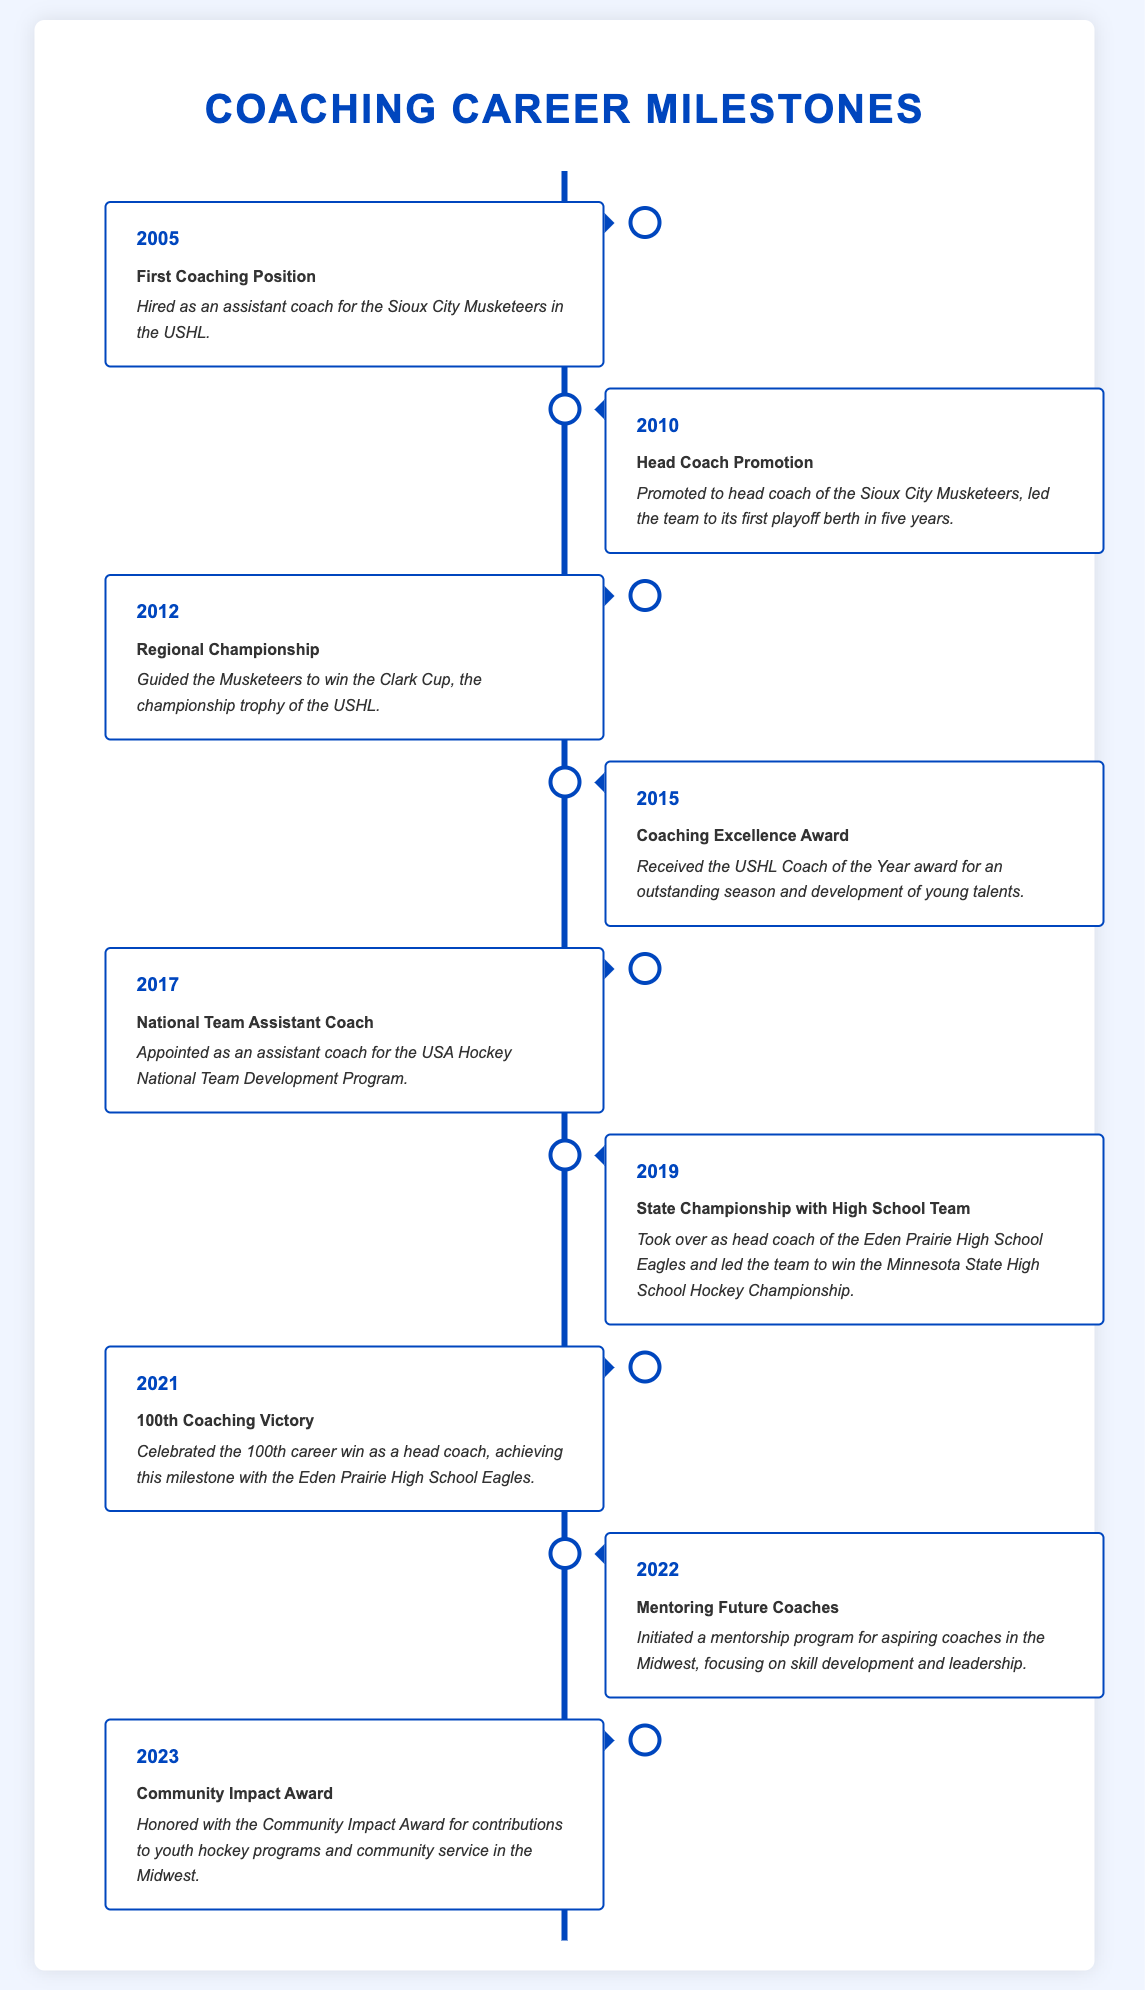what year did the coach start their career? The coach's first coaching position began in 2005, as an assistant coach for the Sioux City Musketeers.
Answer: 2005 which championship did the Musketeers win? The Musketeers won the Clark Cup, the championship trophy of the USHL in 2012.
Answer: Clark Cup how many coaching victories did the coach celebrate in 2021? The coach celebrated his 100th career win as a head coach in 2021.
Answer: 100th what achievement was received in 2015? The coach was awarded the USHL Coach of the Year award for the 2015 season.
Answer: Coaching Excellence Award what program was initiated in 2022? In 2022, the coach initiated a mentorship program for aspiring coaches in the Midwest.
Answer: Mentorship program how many years were there between the first coaching position and the head coach promotion? The head coach promotion occurred in 2010, five years after starting in 2005.
Answer: 5 years what role was taken in 2017? The coach was appointed as an assistant coach for the USA Hockey National Team Development Program in 2017.
Answer: Assistant coach what was the main focus of the mentorship program? The mentorship program focuses on skill development and leadership for aspiring coaches.
Answer: Skill development and leadership 